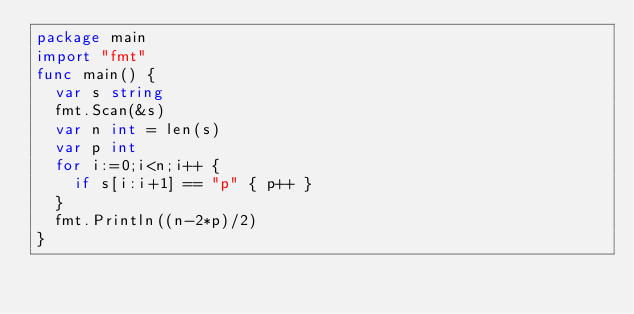<code> <loc_0><loc_0><loc_500><loc_500><_Go_>package main
import "fmt"
func main() {
  var s string
  fmt.Scan(&s)
  var n int = len(s)
  var p int
  for i:=0;i<n;i++ {
    if s[i:i+1] == "p" { p++ }
  }
  fmt.Println((n-2*p)/2)
}</code> 